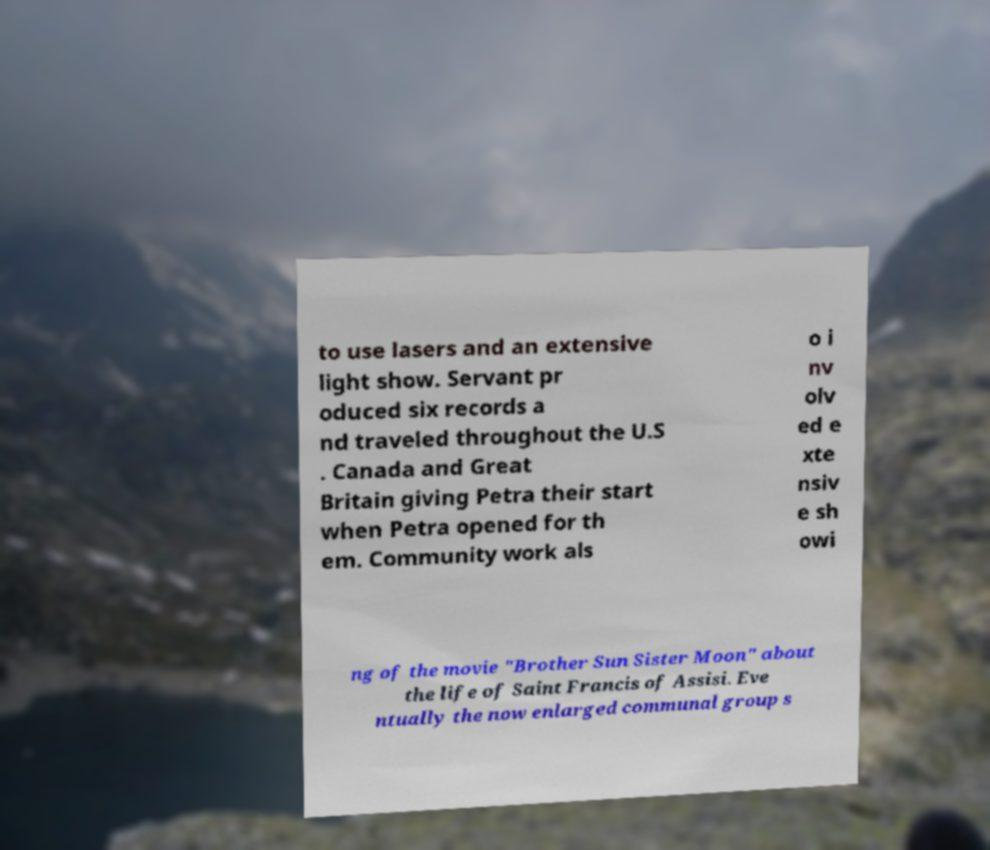Please identify and transcribe the text found in this image. to use lasers and an extensive light show. Servant pr oduced six records a nd traveled throughout the U.S . Canada and Great Britain giving Petra their start when Petra opened for th em. Community work als o i nv olv ed e xte nsiv e sh owi ng of the movie "Brother Sun Sister Moon" about the life of Saint Francis of Assisi. Eve ntually the now enlarged communal group s 